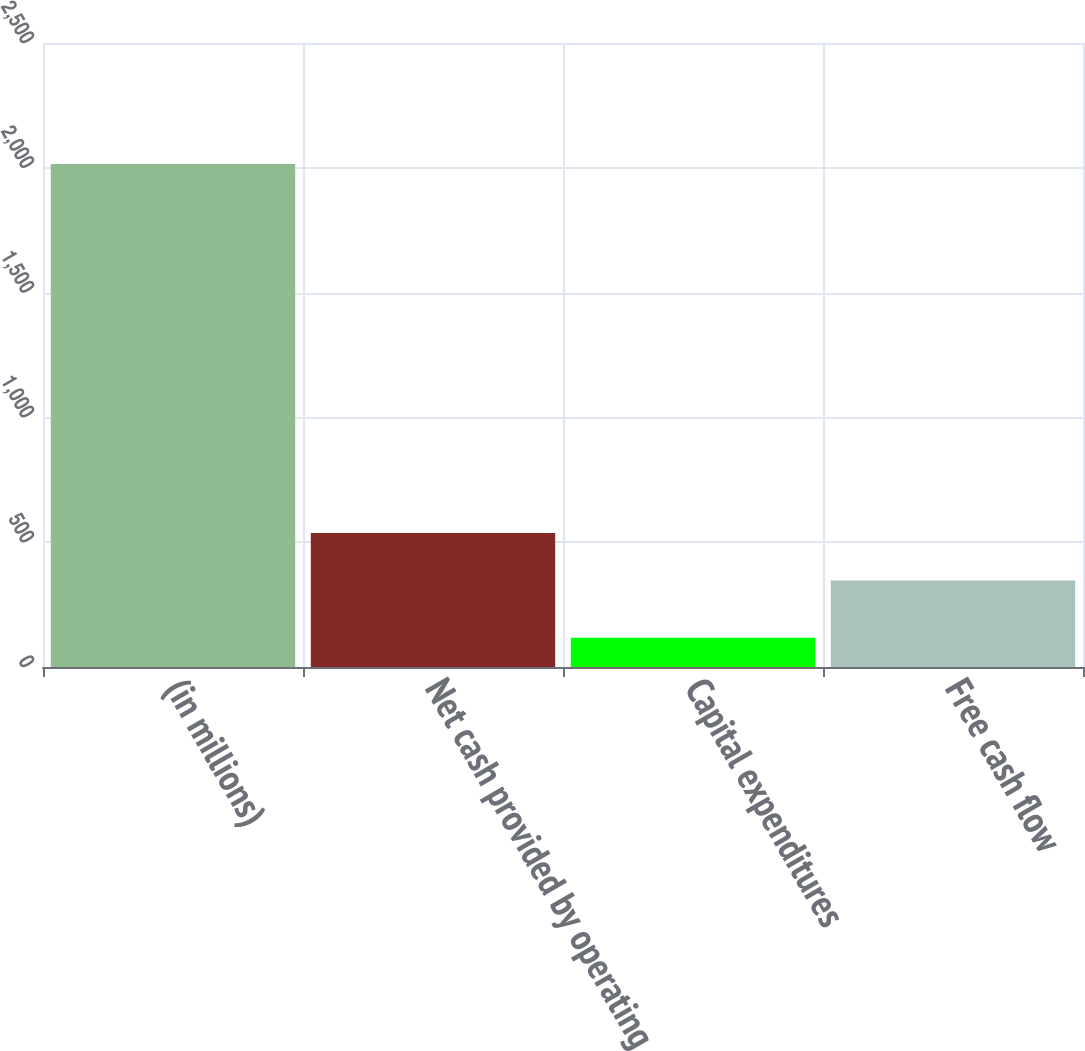Convert chart to OTSL. <chart><loc_0><loc_0><loc_500><loc_500><bar_chart><fcel>(in millions)<fcel>Net cash provided by operating<fcel>Capital expenditures<fcel>Free cash flow<nl><fcel>2015<fcel>536.8<fcel>117<fcel>347<nl></chart> 